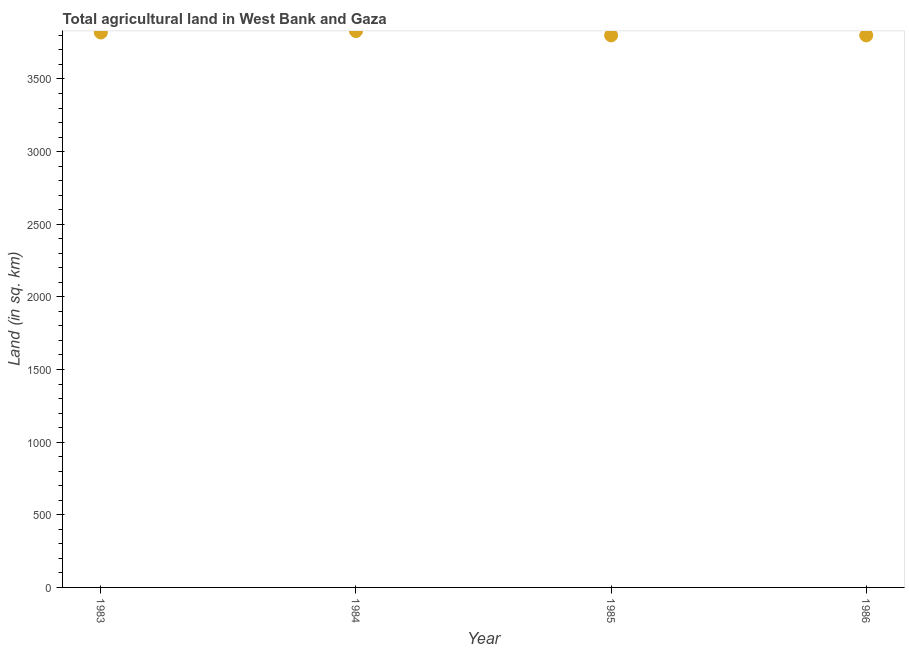What is the agricultural land in 1985?
Keep it short and to the point. 3800. Across all years, what is the maximum agricultural land?
Your answer should be compact. 3830. Across all years, what is the minimum agricultural land?
Your answer should be very brief. 3800. In which year was the agricultural land maximum?
Offer a terse response. 1984. In which year was the agricultural land minimum?
Ensure brevity in your answer.  1985. What is the sum of the agricultural land?
Provide a short and direct response. 1.52e+04. What is the difference between the agricultural land in 1984 and 1985?
Provide a succinct answer. 30. What is the average agricultural land per year?
Keep it short and to the point. 3812.5. What is the median agricultural land?
Make the answer very short. 3810. What is the ratio of the agricultural land in 1983 to that in 1986?
Offer a very short reply. 1.01. Is the agricultural land in 1984 less than that in 1985?
Your response must be concise. No. What is the difference between the highest and the lowest agricultural land?
Provide a succinct answer. 30. In how many years, is the agricultural land greater than the average agricultural land taken over all years?
Your answer should be compact. 2. How many years are there in the graph?
Keep it short and to the point. 4. Are the values on the major ticks of Y-axis written in scientific E-notation?
Keep it short and to the point. No. Does the graph contain any zero values?
Keep it short and to the point. No. Does the graph contain grids?
Your answer should be compact. No. What is the title of the graph?
Offer a very short reply. Total agricultural land in West Bank and Gaza. What is the label or title of the Y-axis?
Make the answer very short. Land (in sq. km). What is the Land (in sq. km) in 1983?
Provide a succinct answer. 3820. What is the Land (in sq. km) in 1984?
Provide a short and direct response. 3830. What is the Land (in sq. km) in 1985?
Make the answer very short. 3800. What is the Land (in sq. km) in 1986?
Offer a terse response. 3800. What is the difference between the Land (in sq. km) in 1983 and 1984?
Provide a succinct answer. -10. What is the difference between the Land (in sq. km) in 1985 and 1986?
Offer a very short reply. 0. What is the ratio of the Land (in sq. km) in 1983 to that in 1985?
Your answer should be compact. 1. What is the ratio of the Land (in sq. km) in 1984 to that in 1985?
Offer a terse response. 1.01. 